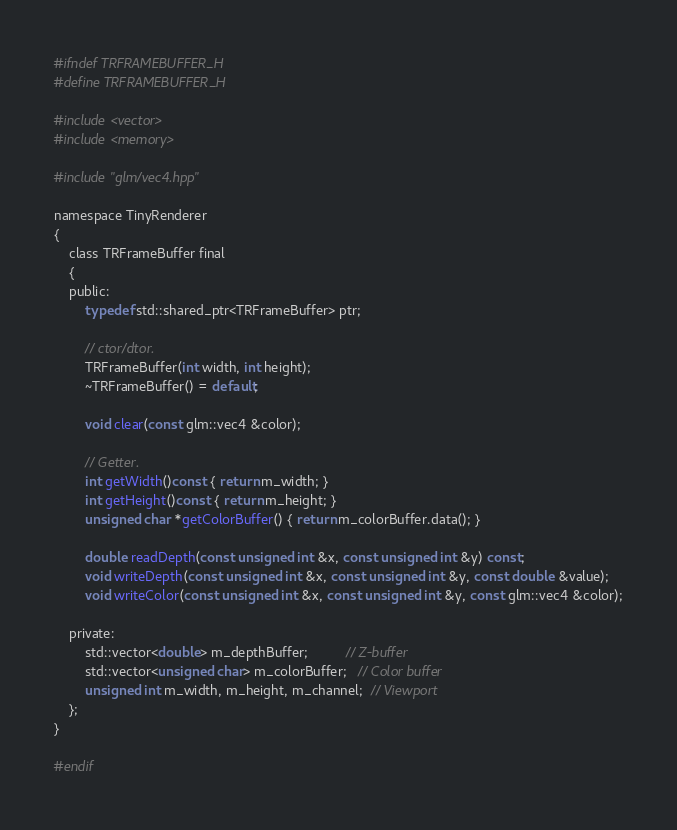Convert code to text. <code><loc_0><loc_0><loc_500><loc_500><_C_>#ifndef TRFRAMEBUFFER_H
#define TRFRAMEBUFFER_H

#include <vector>
#include <memory>

#include "glm/vec4.hpp"

namespace TinyRenderer
{
	class TRFrameBuffer final
	{
	public:
		typedef std::shared_ptr<TRFrameBuffer> ptr;

		// ctor/dtor.
		TRFrameBuffer(int width, int height);
		~TRFrameBuffer() = default;

		void clear(const glm::vec4 &color);

		// Getter.
		int getWidth()const { return m_width; }
		int getHeight()const { return m_height; }
		unsigned char *getColorBuffer() { return m_colorBuffer.data(); }

		double readDepth(const unsigned int &x, const unsigned int &y) const;
		void writeDepth(const unsigned int &x, const unsigned int &y, const double &value);
		void writeColor(const unsigned int &x, const unsigned int &y, const glm::vec4 &color);

	private:
		std::vector<double> m_depthBuffer;          // Z-buffer
		std::vector<unsigned char> m_colorBuffer;   // Color buffer
		unsigned int m_width, m_height, m_channel;  // Viewport
	};
}

#endif</code> 